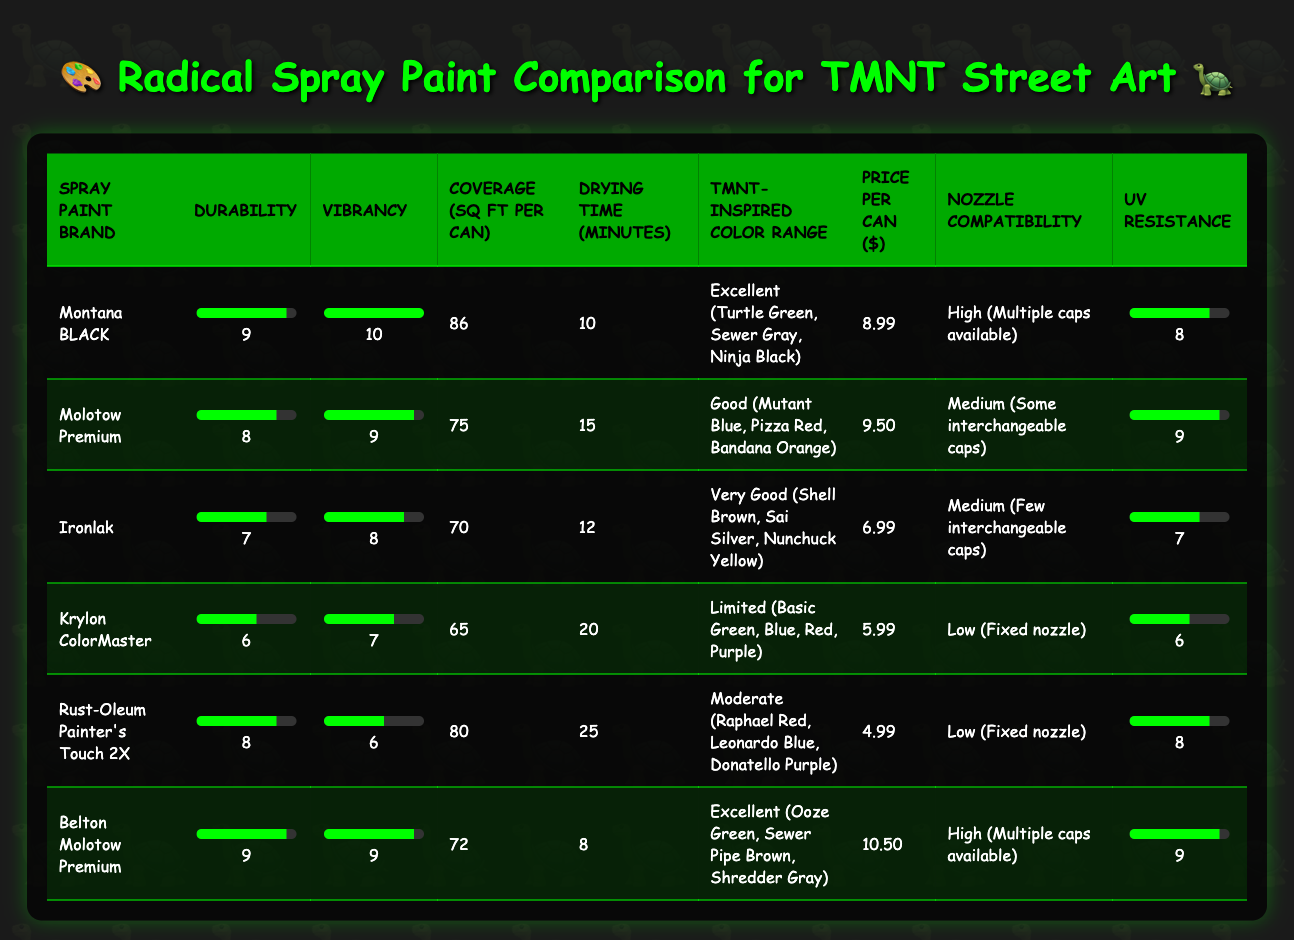What is the most durable spray paint brand? The durability ratings for all brands are listed in the table, with Montana BLACK having the highest score of 9.
Answer: Montana BLACK Which spray paint brand has the best vibrancy? The vibrancy ratings show that Montana BLACK scored a perfect 10, making it the most vibrant option available.
Answer: Montana BLACK What's the average coverage of the spray paint brands listed? To find the average coverage, add the coverage values (86 + 75 + 70 + 65 + 80 + 72) = 448 and divide by the number of brands (6), yielding an average coverage of 74.67 square feet per can.
Answer: 74.67 sq ft Is the price of Rust-Oleum Painter's Touch 2X less than $5? Rust-Oleum Painter's Touch 2X is priced at $4.99, which is indeed less than $5, confirming the statement is true.
Answer: Yes Which brand has the combination of the best durability and vibrancy? By examining the table, both Montana BLACK and Belton Molotow Premium scored a high durability of 9 and vibrancy of 10 and 9, respectively. Montana BLACK holds the strongest combination in this case.
Answer: Montana BLACK What is the difference in UV resistance between Ironlak and Molotow Premium? Ironlak has a UV resistance rating of 7 while Molotow Premium has a rating of 9. The difference is 9 - 7 = 2.
Answer: 2 Which spray paint is the cheapest per can and how much is it? Reviewing the price column, Rust-Oleum Painter's Touch 2X is the cheapest at $4.99 per can.
Answer: $4.99 How many spray paint brands have a UV resistance rating of 8 or higher? Checking the UV resistance ratings, we find 4 brands: Montana BLACK, Molotow Premium, Belton Molotow Premium, and Rust-Oleum Painter's Touch 2X have ratings of 8 or above.
Answer: 4 Is there a spray paint brand that offers more than 80 square feet of coverage? Yes, the brands Montana BLACK and Rust-Oleum Painter's Touch 2X both offer more than 80 square feet of coverage, with Montana BLACK providing 86 sq ft.
Answer: Yes 